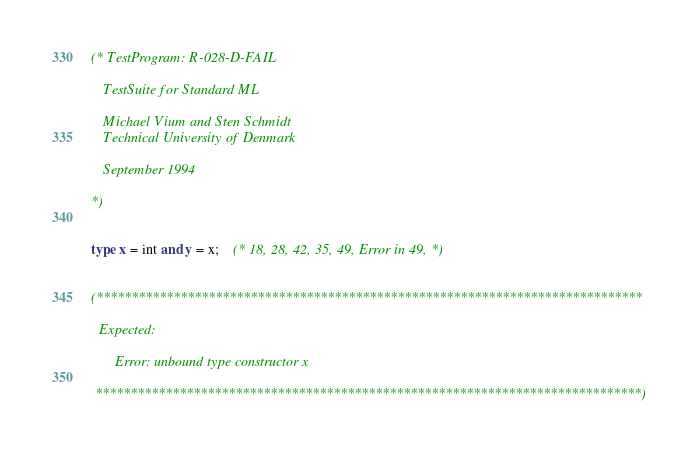Convert code to text. <code><loc_0><loc_0><loc_500><loc_500><_SML_>(* TestProgram: R-028-D-FAIL

   TestSuite for Standard ML

   Michael Vium and Sten Schmidt
   Technical University of Denmark

   September 1994

*)


type x = int and y = x;    (* 18, 28, 42, 35, 49, Error in 49, *)


(******************************************************************************

  Expected:

      Error: unbound type constructor x

 ******************************************************************************)


</code> 